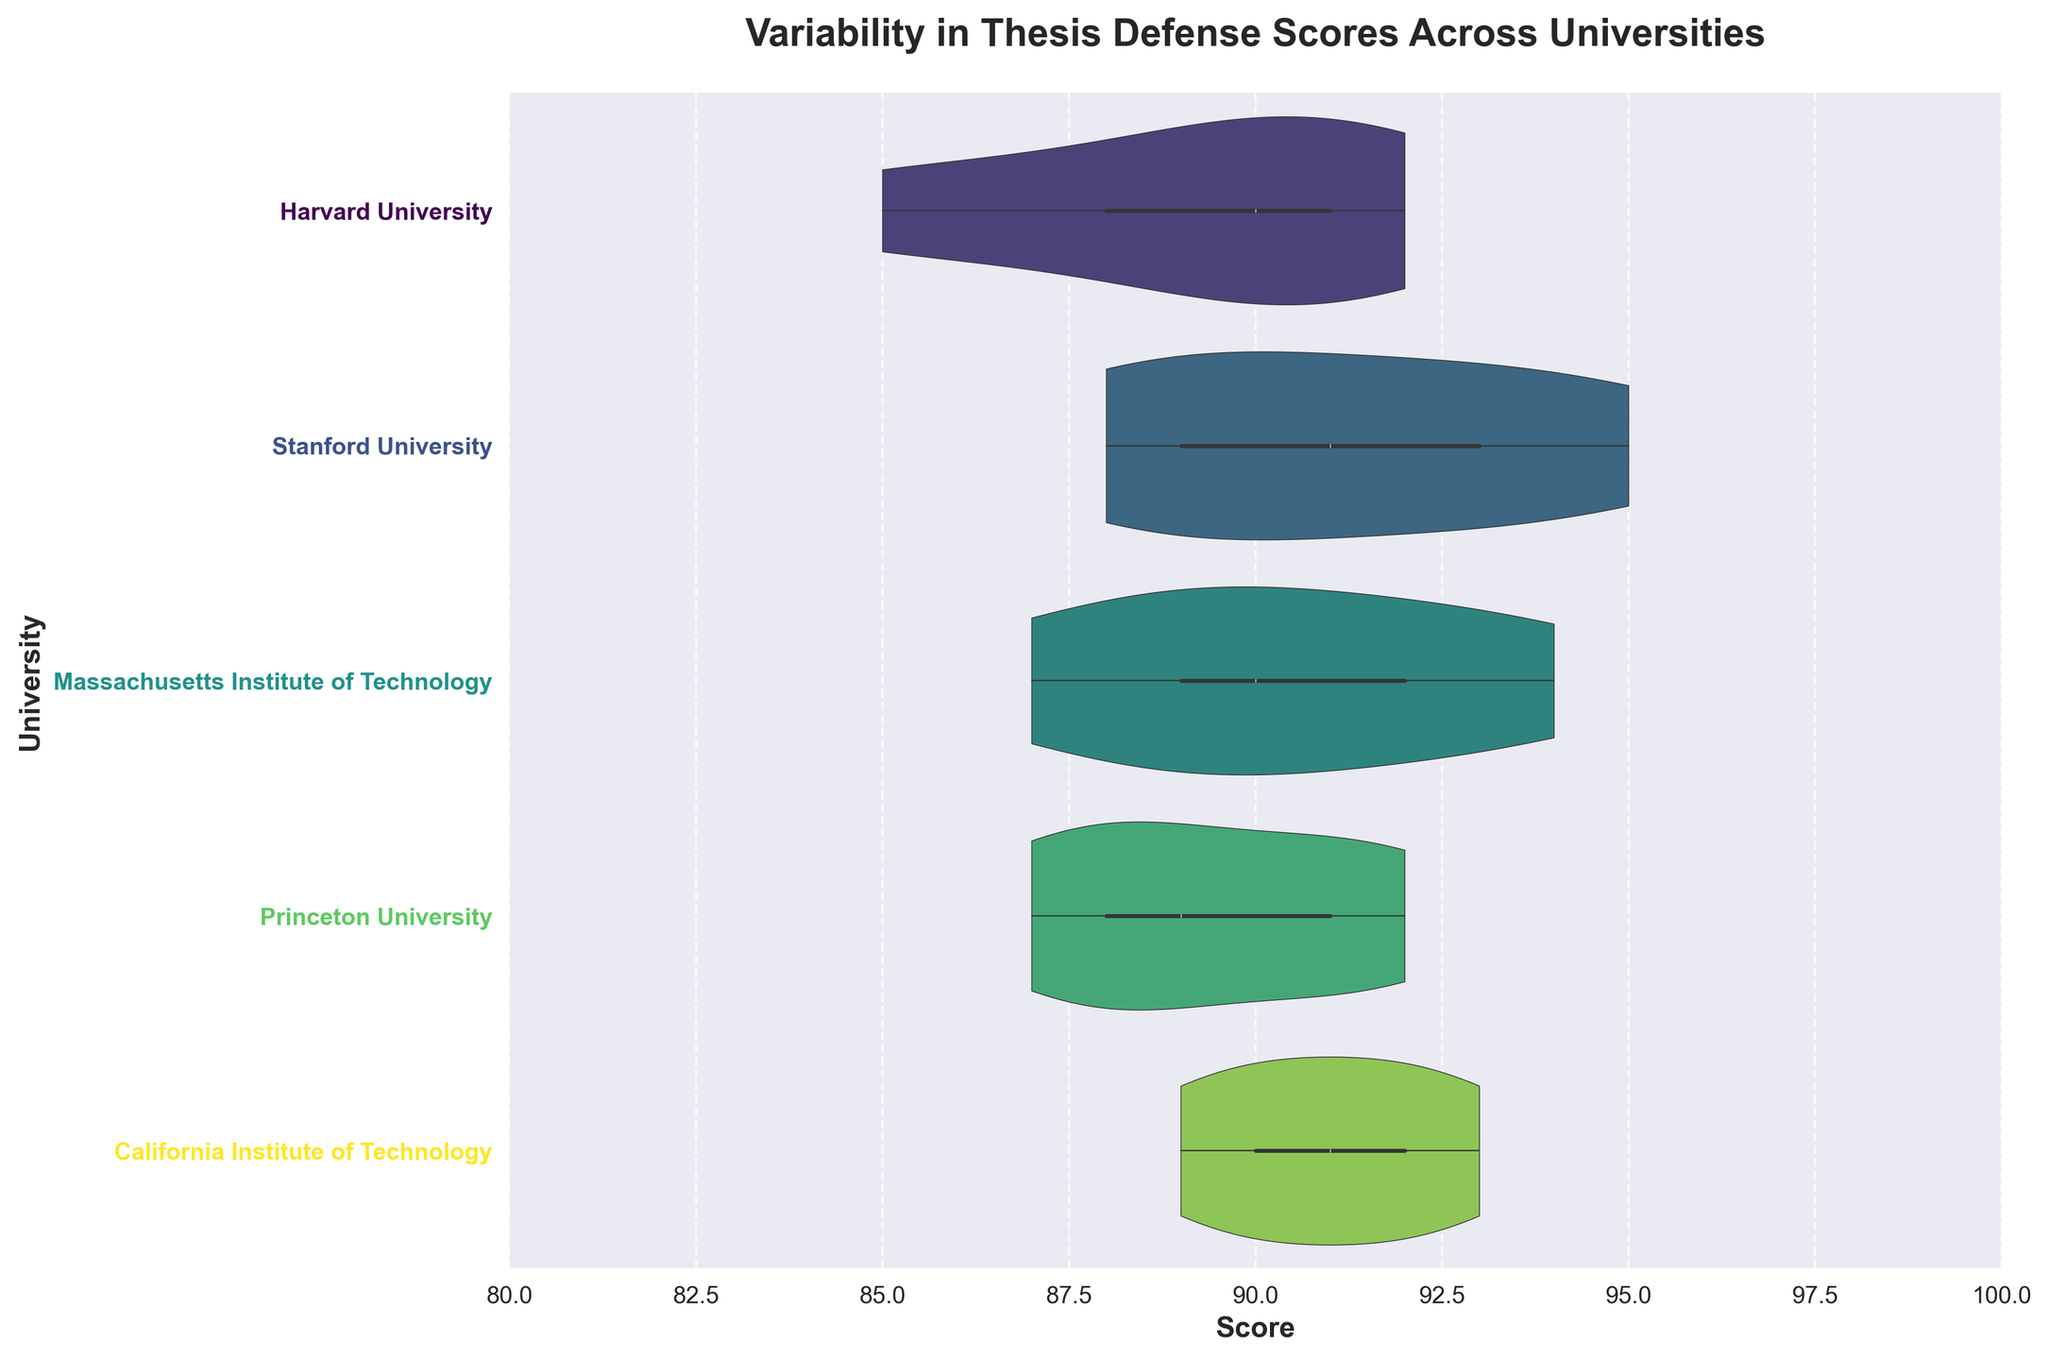What is the title of the plot? The title of the plot is displayed prominently at the top of the figure. The exact text in the title can be read directly from the plot.
Answer: Variability in Thesis Defense Scores Across Universities What is the range of scores on the x-axis in the plot? The range of scores on the x-axis can be identified by looking at the labeled limits on the x-axis. It is explicitly shown on the figure.
Answer: 80 to 100 How does the median score for Harvard University compare to the median score for Stanford University? The violin plot includes a box plot within it that shows the median. Comparing the median lines within the violins for Harvard University and Stanford University, we can see which median lies higher.
Answer: The median score for Stanford University is higher than that for Harvard University What is the interquartile range (IQR) for Massachusetts Institute of Technology? The IQR is the range between the 25th and 75th percentiles, visible in the box plot within the violin. By examining the box plot for MIT, these percentiles can be measured along the x-axis.
Answer: MIT's IQR is approximately from 88 to 92 Which university has the widest spread of scores? The spread of scores can be identified by looking at the width of the violin plots for each university. The university with the widest violin plot has the most variability in scores.
Answer: Harvard University Are there any outliers visible in the scores for Princeton University? Outliers in the data would be typically marked with distinct points outside the thick vi plots. By examining the violin plot for Princeton University, one can see if such points exist.
Answer: No, there are no outliers visible for Princeton University Which university has the narrowest range of scores? The range of scores is indicated by the width of the violin plots. The university with the narrowest violin plot has the smallest range of scores.
Answer: Massachusetts Institute of Technology What is the highest score observed for California Institute of Technology? The highest score can be found by looking at the farthest right extent of the violin plot for Caltech. This point on the x-axis represents the highest score.
Answer: 93 Compare the distribution of scores for Princeton University and Harvard University. Which university shows more variability? Variability can be understood by assessing the shape and width of the violin plots. A wider and more varied shape indicates more variability. Comparing the violin plots for Princeton and Harvard, one can see which is broader and more spread out.
Answer: Harvard University shows more variability 